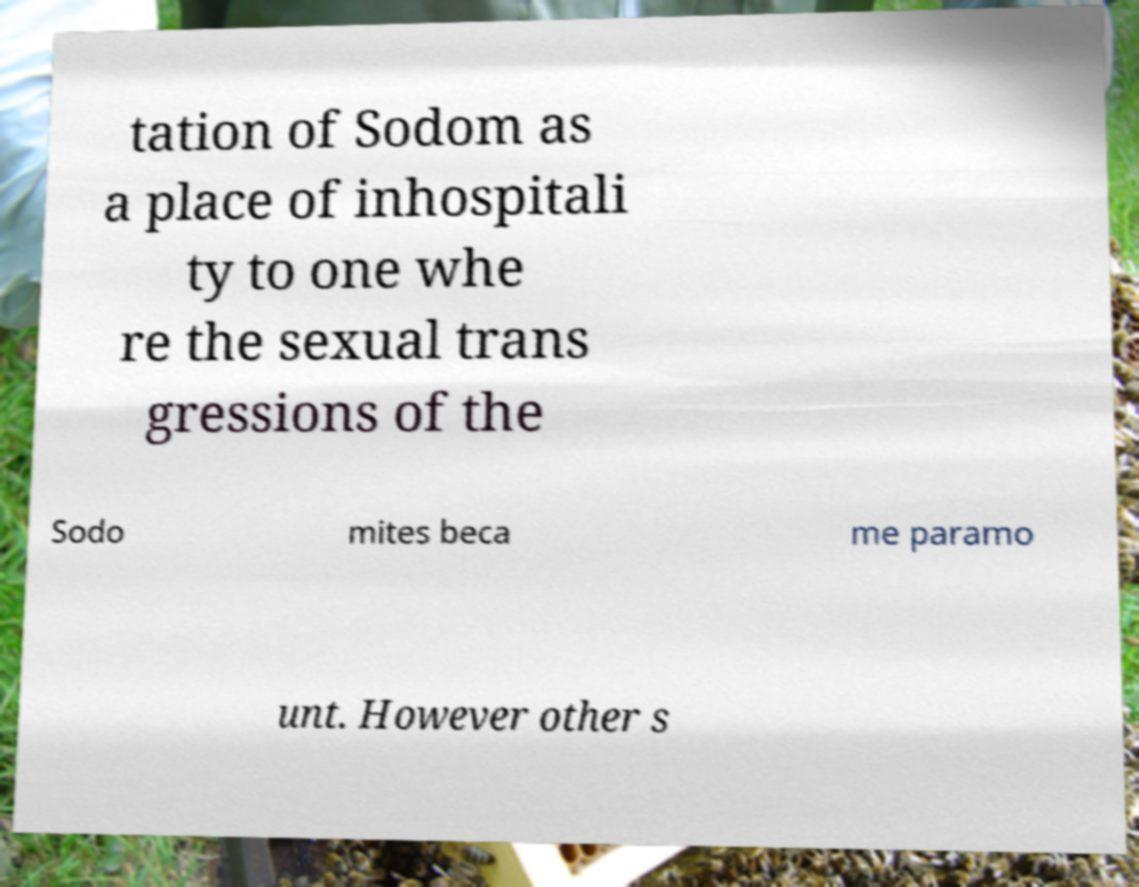I need the written content from this picture converted into text. Can you do that? tation of Sodom as a place of inhospitali ty to one whe re the sexual trans gressions of the Sodo mites beca me paramo unt. However other s 